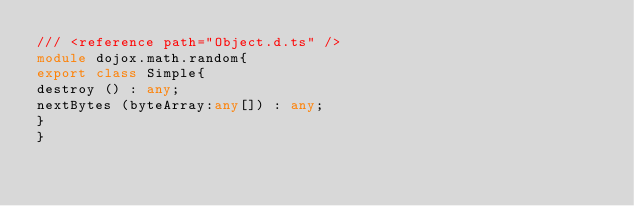<code> <loc_0><loc_0><loc_500><loc_500><_TypeScript_>/// <reference path="Object.d.ts" />
module dojox.math.random{
export class Simple{
destroy () : any;
nextBytes (byteArray:any[]) : any;
}
}
</code> 